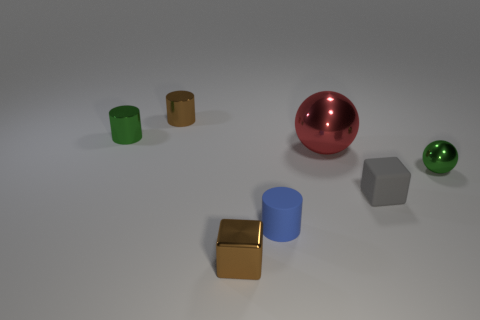Subtract all shiny cylinders. How many cylinders are left? 1 Subtract all green balls. How many balls are left? 1 Add 3 big purple rubber spheres. How many objects exist? 10 Subtract 1 balls. How many balls are left? 1 Subtract all cylinders. How many objects are left? 4 Subtract all gray blocks. Subtract all gray cylinders. How many blocks are left? 1 Subtract all blue rubber things. Subtract all blue matte cylinders. How many objects are left? 5 Add 5 tiny green shiny balls. How many tiny green shiny balls are left? 6 Add 7 brown shiny balls. How many brown shiny balls exist? 7 Subtract 0 cyan balls. How many objects are left? 7 